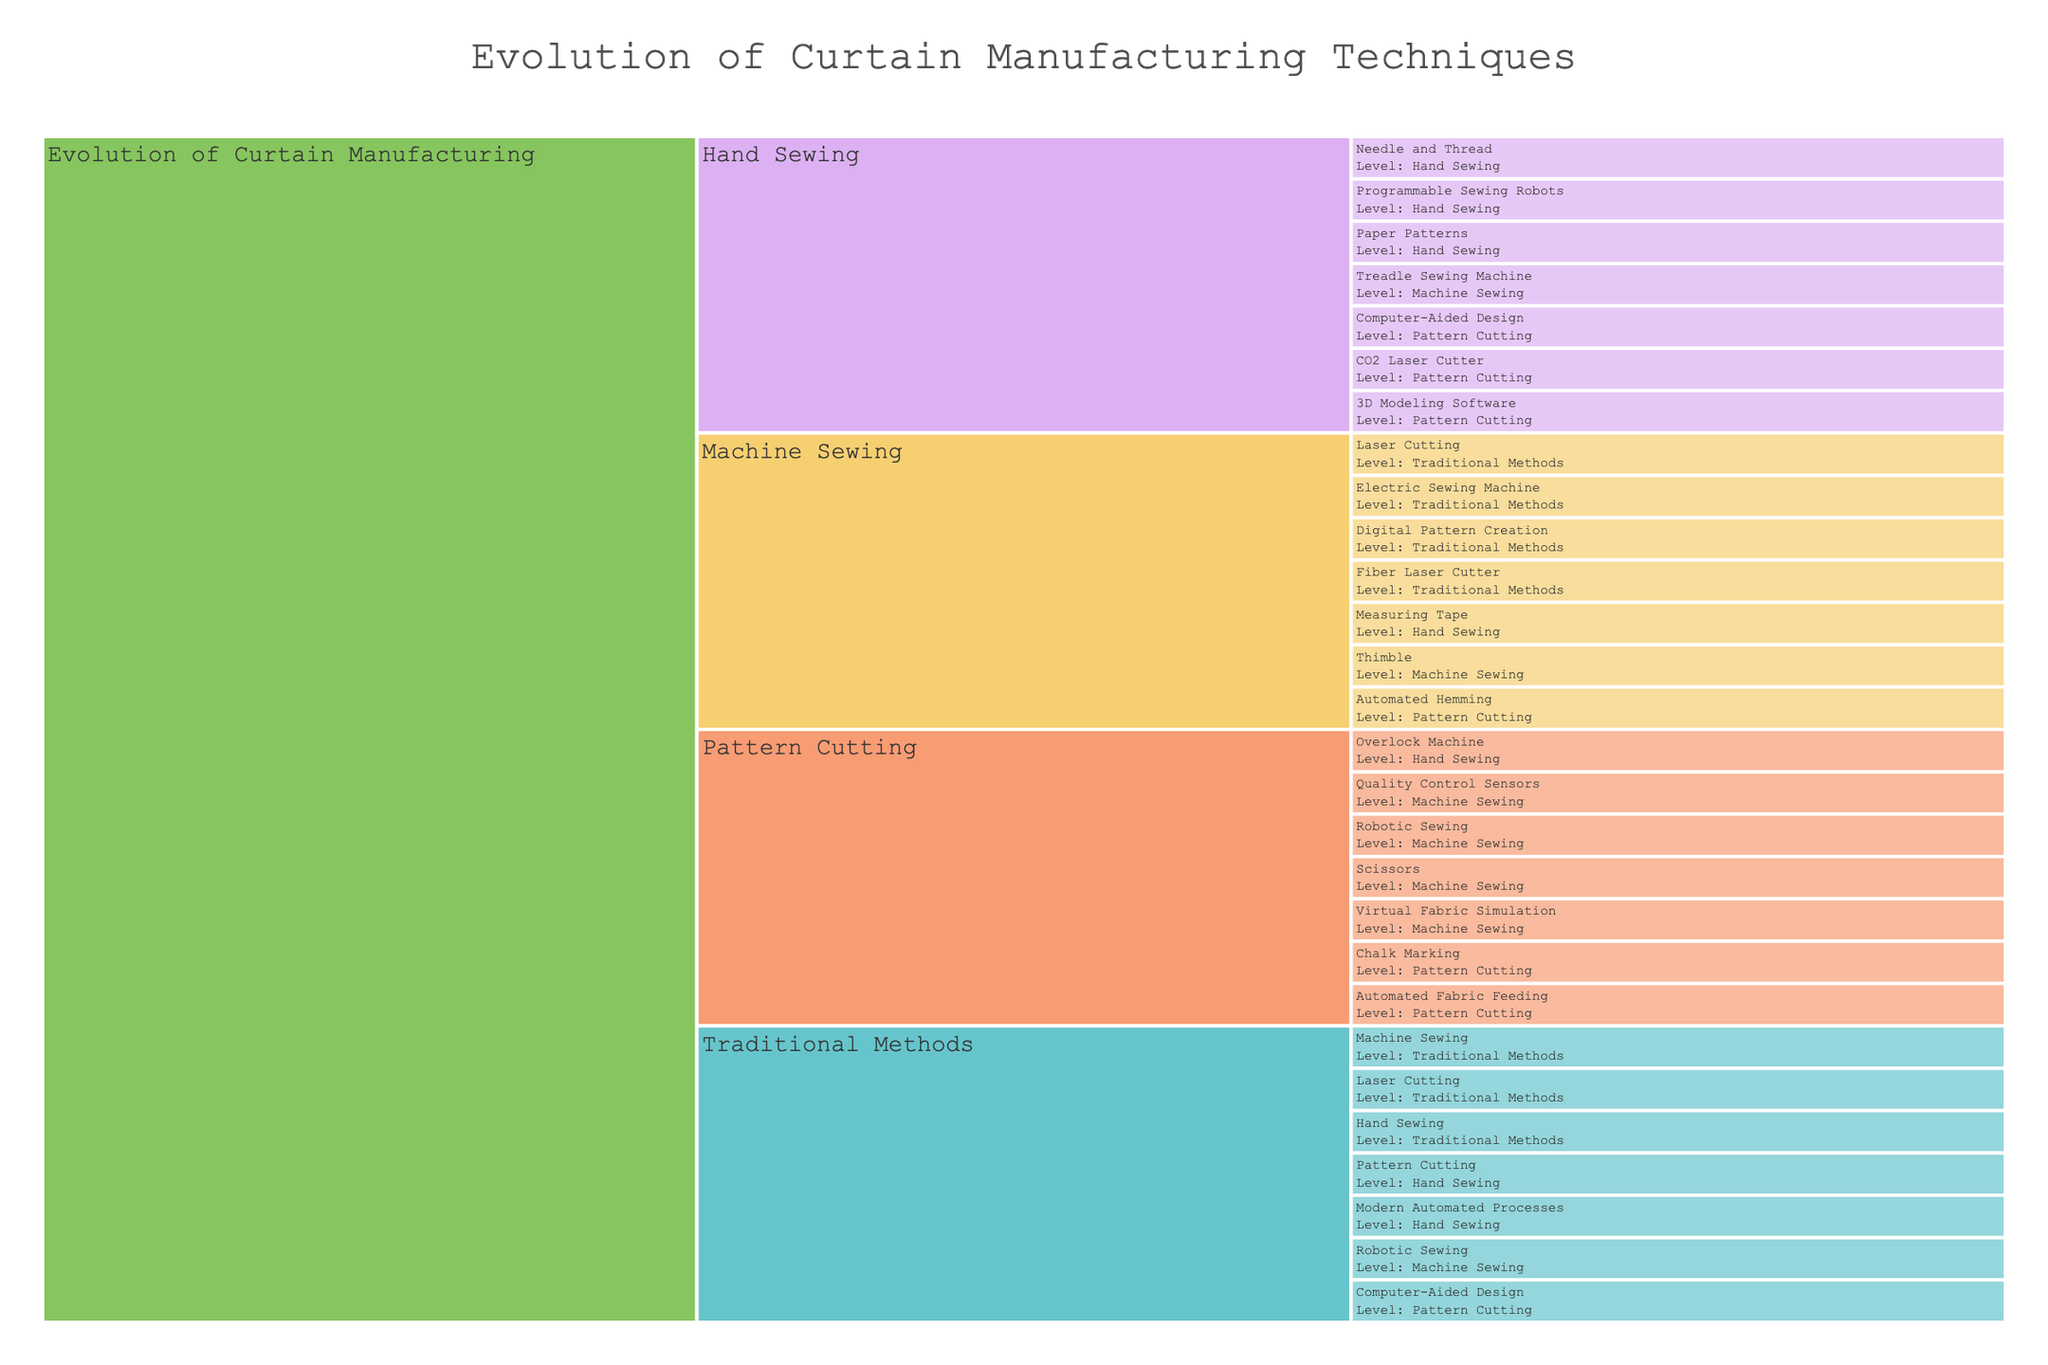What is the title of the chart? The title is displayed at the top-center of the plot. It is the largest text in the plot and typically describes the main subject.
Answer: Evolution of Curtain Manufacturing Techniques How many levels of manufacturing techniques are displayed under 'Traditional Methods'? Count the different categories mentioned under 'Traditional Methods' which include 'Hand Sewing', 'Machine Sewing', and 'Pattern Cutting'.
Answer: 3 Which component under 'Modern Automated Processes' uses simulation technology? Look for a component under 'Modern Automated Processes' that explicitly mentions simulation. 'Virtual Fabric Simulation' under 'Computer-Aided Design' fits this description.
Answer: Virtual Fabric Simulation What are the tools listed under 'Pattern Cutting' in 'Traditional Methods'? Identify the items listed under 'Pattern Cutting'. According to the data, these are 'Paper Patterns', 'Measuring Tape', and 'Chalk Marking'.
Answer: Paper Patterns, Measuring Tape, Chalk Marking Compare the types of sewing machines under 'Machine Sewing' in 'Traditional Methods'. Identify the types of sewing machines listed under 'Machine Sewing' which include 'Treadle Sewing Machine', 'Electric Sewing Machine', and 'Overlock Machine'.
Answer: Treadle Sewing Machine, Electric Sewing Machine, Overlock Machine Calculate the total number of unique items listed under 'Modern Automated Processes'. Include all the sub-categories and their components. Identify and count each unique entry under 'Modern Automated Processes' which includes 3 entries under 'Computer-Aided Design', 3 under 'Laser Cutting', and 3 under 'Robotic Sewing', totaling 9 unique items.
Answer: 9 Which method involves the use of a 'Thimble'? Locate the category where 'Thimble' is listed. 'Hand Sewing' under 'Traditional Methods' includes 'Thimble'.
Answer: Hand Sewing Identify the category that includes 'Quality Control Sensors'. 'Quality Control Sensors' is part of 'Robotic Sewing' under 'Modern Automated Processes'.
Answer: Robotic Sewing Compare 'Laser Cutting' and 'Paper Patterns' in terms of their classification. Are they under the same method type? Determine the broader classifications of 'Laser Cutting' and 'Pattern Cutting'. 'Laser Cutting' falls under 'Modern Automated Processes' whereas 'Pattern Cutting' is under 'Traditional Methods'.
Answer: No How do 'Virtual Fabric Simulation' and 'Automated Hemming' differ in their broader classification? Find the broader categories for each. 'Virtual Fabric Simulation' is under 'Computer-Aided Design' in 'Modern Automated Processes' and 'Automated Hemming' is under 'Robotic Sewing' in 'Modern Automated Processes'.
Answer: They are both part of 'Modern Automated Processes' but under different sub-categories 